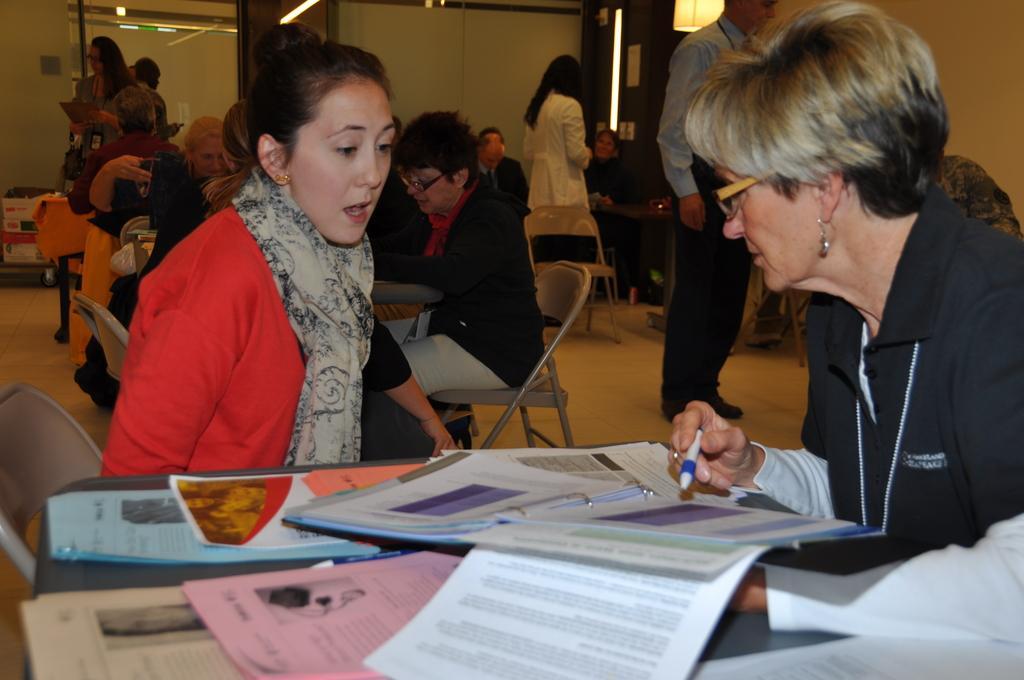Could you give a brief overview of what you see in this image? In this picture we can see some people are sitting on chairs and some people are standing on the floor. In front of the two people there is a table and on the table there are papers and files. A person is holding a pen. Behind the people there is a wall and on the right side of the people there is a light. 